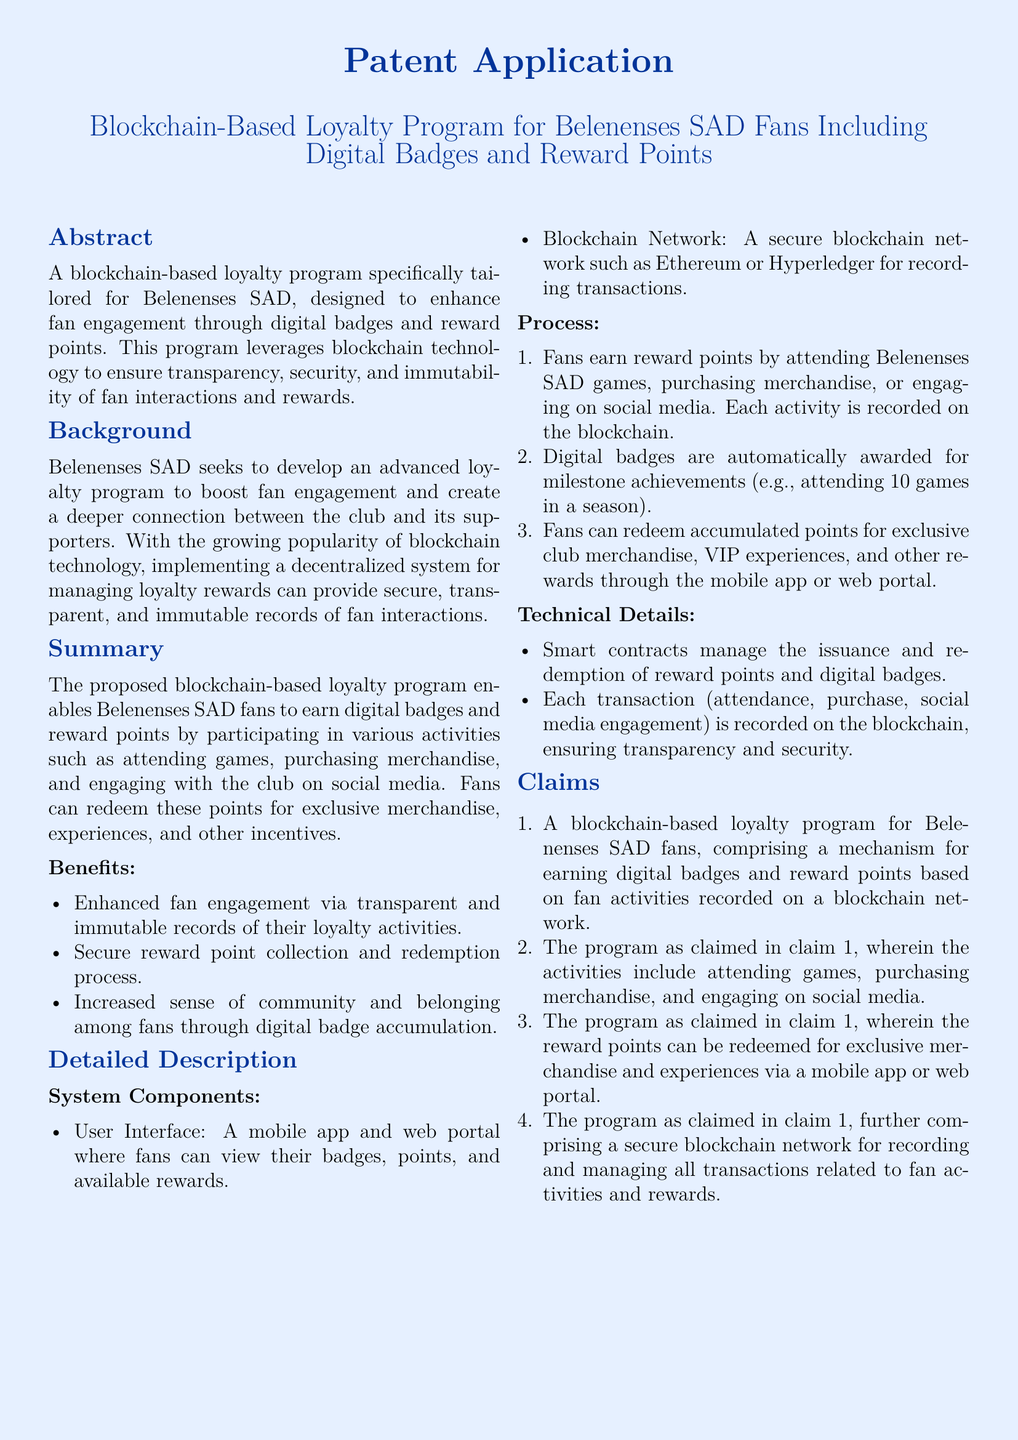What is the title of the patent application? The title of the patent application is mentioned at the top of the document, indicating its focus.
Answer: Blockchain-Based Loyalty Program for Belenenses SAD Fans Including Digital Badges and Reward Points What technology does the loyalty program utilize? The document specifies that the loyalty program leverages a specific technology that offers security and transparency.
Answer: Blockchain technology What milestone is mentioned for earning digital badges? The document lists a specific achievement related to game attendance that qualifies for a digital badge.
Answer: Attending 10 games in a season What type of rewards can fans redeem? The document describes the nature of rewards that fans can obtain through the loyalty program.
Answer: Exclusive merchandise and experiences How many claims are included in the document? The section titled "Claims" outlines the protective features and functionalities, indicating a specific count.
Answer: Four claims What is the primary aim of the loyalty program? The document states the central goal of implementing this loyalty program linking it to fan behavior.
Answer: Boost fan engagement Which platforms are mentioned for user interface access? The document specifies the platforms through which fans can engage with the loyalty program.
Answer: Mobile app and web portal What blockchain network examples are given? The document refers to specific examples of secure blockchain networks for managing transactions.
Answer: Ethereum or Hyperledger What role do smart contracts play in the program? The document describes a specific function of smart contracts within the operational framework of the loyalty program.
Answer: Manage the issuance and redemption of reward points and digital badges 